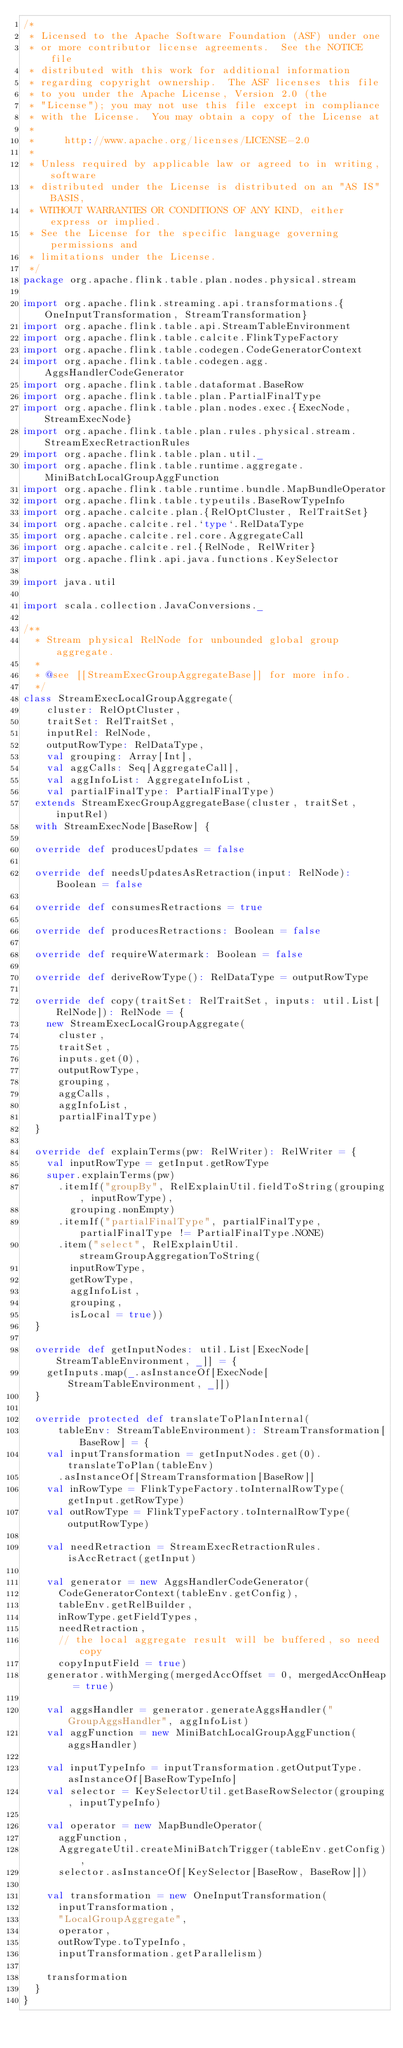<code> <loc_0><loc_0><loc_500><loc_500><_Scala_>/*
 * Licensed to the Apache Software Foundation (ASF) under one
 * or more contributor license agreements.  See the NOTICE file
 * distributed with this work for additional information
 * regarding copyright ownership.  The ASF licenses this file
 * to you under the Apache License, Version 2.0 (the
 * "License"); you may not use this file except in compliance
 * with the License.  You may obtain a copy of the License at
 *
 *     http://www.apache.org/licenses/LICENSE-2.0
 *
 * Unless required by applicable law or agreed to in writing, software
 * distributed under the License is distributed on an "AS IS" BASIS,
 * WITHOUT WARRANTIES OR CONDITIONS OF ANY KIND, either express or implied.
 * See the License for the specific language governing permissions and
 * limitations under the License.
 */
package org.apache.flink.table.plan.nodes.physical.stream

import org.apache.flink.streaming.api.transformations.{OneInputTransformation, StreamTransformation}
import org.apache.flink.table.api.StreamTableEnvironment
import org.apache.flink.table.calcite.FlinkTypeFactory
import org.apache.flink.table.codegen.CodeGeneratorContext
import org.apache.flink.table.codegen.agg.AggsHandlerCodeGenerator
import org.apache.flink.table.dataformat.BaseRow
import org.apache.flink.table.plan.PartialFinalType
import org.apache.flink.table.plan.nodes.exec.{ExecNode, StreamExecNode}
import org.apache.flink.table.plan.rules.physical.stream.StreamExecRetractionRules
import org.apache.flink.table.plan.util._
import org.apache.flink.table.runtime.aggregate.MiniBatchLocalGroupAggFunction
import org.apache.flink.table.runtime.bundle.MapBundleOperator
import org.apache.flink.table.typeutils.BaseRowTypeInfo
import org.apache.calcite.plan.{RelOptCluster, RelTraitSet}
import org.apache.calcite.rel.`type`.RelDataType
import org.apache.calcite.rel.core.AggregateCall
import org.apache.calcite.rel.{RelNode, RelWriter}
import org.apache.flink.api.java.functions.KeySelector

import java.util

import scala.collection.JavaConversions._

/**
  * Stream physical RelNode for unbounded global group aggregate.
  *
  * @see [[StreamExecGroupAggregateBase]] for more info.
  */
class StreamExecLocalGroupAggregate(
    cluster: RelOptCluster,
    traitSet: RelTraitSet,
    inputRel: RelNode,
    outputRowType: RelDataType,
    val grouping: Array[Int],
    val aggCalls: Seq[AggregateCall],
    val aggInfoList: AggregateInfoList,
    val partialFinalType: PartialFinalType)
  extends StreamExecGroupAggregateBase(cluster, traitSet, inputRel)
  with StreamExecNode[BaseRow] {

  override def producesUpdates = false

  override def needsUpdatesAsRetraction(input: RelNode): Boolean = false

  override def consumesRetractions = true

  override def producesRetractions: Boolean = false

  override def requireWatermark: Boolean = false

  override def deriveRowType(): RelDataType = outputRowType

  override def copy(traitSet: RelTraitSet, inputs: util.List[RelNode]): RelNode = {
    new StreamExecLocalGroupAggregate(
      cluster,
      traitSet,
      inputs.get(0),
      outputRowType,
      grouping,
      aggCalls,
      aggInfoList,
      partialFinalType)
  }

  override def explainTerms(pw: RelWriter): RelWriter = {
    val inputRowType = getInput.getRowType
    super.explainTerms(pw)
      .itemIf("groupBy", RelExplainUtil.fieldToString(grouping, inputRowType),
        grouping.nonEmpty)
      .itemIf("partialFinalType", partialFinalType, partialFinalType != PartialFinalType.NONE)
      .item("select", RelExplainUtil.streamGroupAggregationToString(
        inputRowType,
        getRowType,
        aggInfoList,
        grouping,
        isLocal = true))
  }

  override def getInputNodes: util.List[ExecNode[StreamTableEnvironment, _]] = {
    getInputs.map(_.asInstanceOf[ExecNode[StreamTableEnvironment, _]])
  }

  override protected def translateToPlanInternal(
      tableEnv: StreamTableEnvironment): StreamTransformation[BaseRow] = {
    val inputTransformation = getInputNodes.get(0).translateToPlan(tableEnv)
      .asInstanceOf[StreamTransformation[BaseRow]]
    val inRowType = FlinkTypeFactory.toInternalRowType(getInput.getRowType)
    val outRowType = FlinkTypeFactory.toInternalRowType(outputRowType)

    val needRetraction = StreamExecRetractionRules.isAccRetract(getInput)

    val generator = new AggsHandlerCodeGenerator(
      CodeGeneratorContext(tableEnv.getConfig),
      tableEnv.getRelBuilder,
      inRowType.getFieldTypes,
      needRetraction,
      // the local aggregate result will be buffered, so need copy
      copyInputField = true)
    generator.withMerging(mergedAccOffset = 0, mergedAccOnHeap = true)

    val aggsHandler = generator.generateAggsHandler("GroupAggsHandler", aggInfoList)
    val aggFunction = new MiniBatchLocalGroupAggFunction(aggsHandler)

    val inputTypeInfo = inputTransformation.getOutputType.asInstanceOf[BaseRowTypeInfo]
    val selector = KeySelectorUtil.getBaseRowSelector(grouping, inputTypeInfo)

    val operator = new MapBundleOperator(
      aggFunction,
      AggregateUtil.createMiniBatchTrigger(tableEnv.getConfig),
      selector.asInstanceOf[KeySelector[BaseRow, BaseRow]])

    val transformation = new OneInputTransformation(
      inputTransformation,
      "LocalGroupAggregate",
      operator,
      outRowType.toTypeInfo,
      inputTransformation.getParallelism)

    transformation
  }
}
</code> 